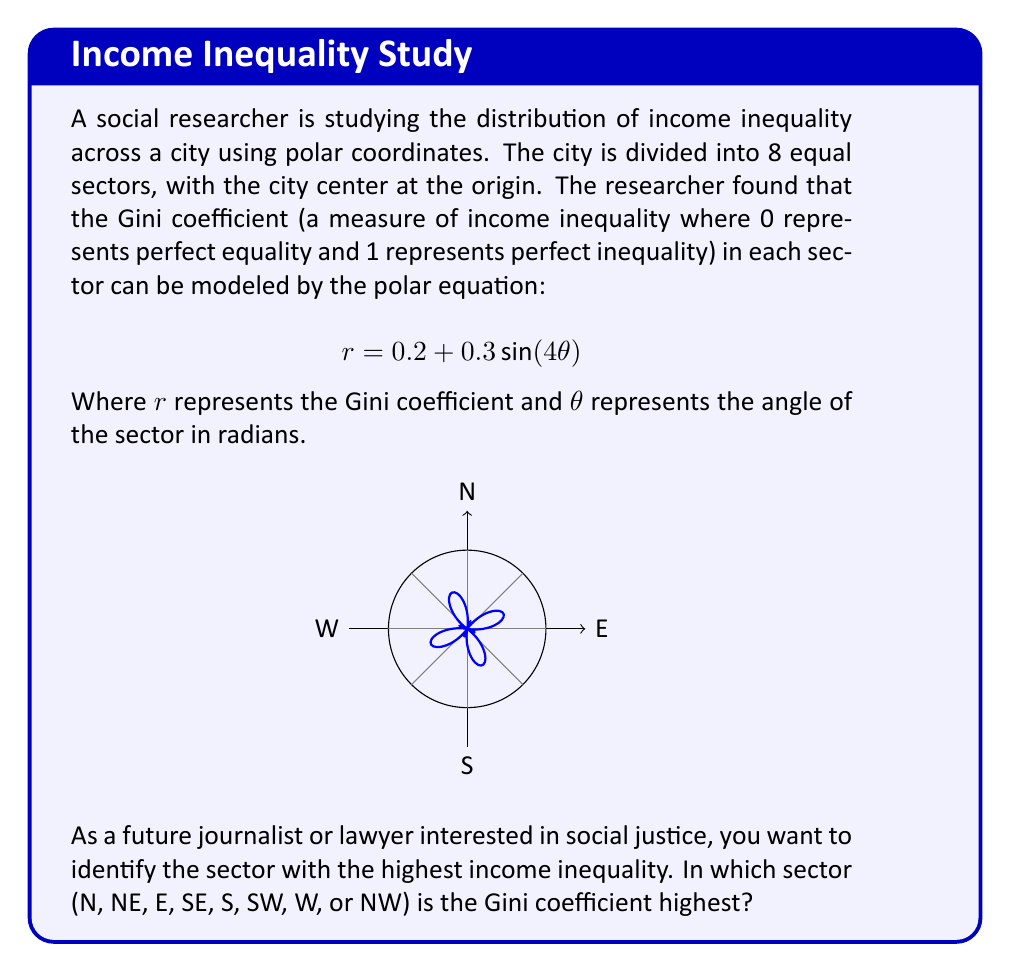What is the answer to this math problem? To solve this problem, we need to follow these steps:

1) The city is divided into 8 equal sectors, so each sector covers an angle of $\frac{2\pi}{8} = \frac{\pi}{4}$ radians.

2) The sectors correspond to the following angles:
   N: $\frac{\pi}{2}$, NE: $\frac{\pi}{4}$, E: 0, SE: $\frac{7\pi}{4}$, 
   S: $\frac{3\pi}{2}$, SW: $\frac{5\pi}{4}$, W: $\pi$, NW: $\frac{3\pi}{4}$

3) We need to evaluate $r = 0.2 + 0.3\sin(4\theta)$ for each of these angles:

   N:  $r = 0.2 + 0.3\sin(4 \cdot \frac{\pi}{2}) = 0.2 + 0.3\sin(2\pi) = 0.2$
   NE: $r = 0.2 + 0.3\sin(4 \cdot \frac{\pi}{4}) = 0.2 + 0.3\sin(\pi) = 0.2$
   E:  $r = 0.2 + 0.3\sin(4 \cdot 0) = 0.2 + 0.3\sin(0) = 0.2$
   SE: $r = 0.2 + 0.3\sin(4 \cdot \frac{7\pi}{4}) = 0.2 + 0.3\sin(7\pi) = 0.2$
   S:  $r = 0.2 + 0.3\sin(4 \cdot \frac{3\pi}{2}) = 0.2 + 0.3\sin(6\pi) = 0.2$
   SW: $r = 0.2 + 0.3\sin(4 \cdot \frac{5\pi}{4}) = 0.2 + 0.3\sin(5\pi) = 0.2$
   W:  $r = 0.2 + 0.3\sin(4 \cdot \pi) = 0.2 + 0.3\sin(4\pi) = 0.2$
   NW: $r = 0.2 + 0.3\sin(4 \cdot \frac{3\pi}{4}) = 0.2 + 0.3\sin(3\pi) = 0.2$

4) We can see that the Gini coefficient is the same (0.2) in all sectors. However, this doesn't mean there's no variation. The function oscillates between its maximum and minimum values four times as $\theta$ goes from 0 to $2\pi$.

5) To find the maximum value, we need to solve:
   $\frac{d}{d\theta}(0.2 + 0.3\sin(4\theta)) = 1.2\cos(4\theta) = 0$
   This occurs when $4\theta = \frac{\pi}{2}, \frac{3\pi}{2}, \frac{5\pi}{2}, \frac{7\pi}{2}$
   Or when $\theta = \frac{\pi}{8}, \frac{3\pi}{8}, \frac{5\pi}{8}, \frac{7\pi}{8}$

6) The maximum value occurs at these points:
   $r_{max} = 0.2 + 0.3\sin(4 \cdot \frac{\pi}{8}) = 0.2 + 0.3 = 0.5$

7) The angles $\frac{\pi}{8}$ and $\frac{3\pi}{8}$ fall in the NE sector.
Answer: NE 